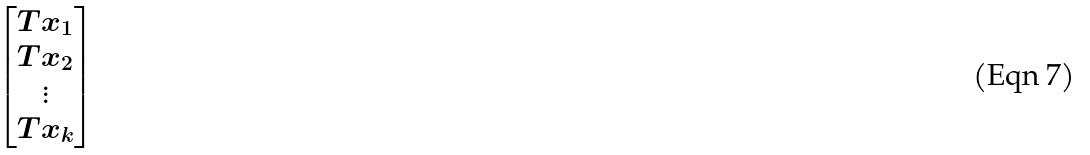<formula> <loc_0><loc_0><loc_500><loc_500>\begin{bmatrix} T x _ { 1 } \\ T x _ { 2 } \\ \vdots \\ T x _ { k } \end{bmatrix}</formula> 